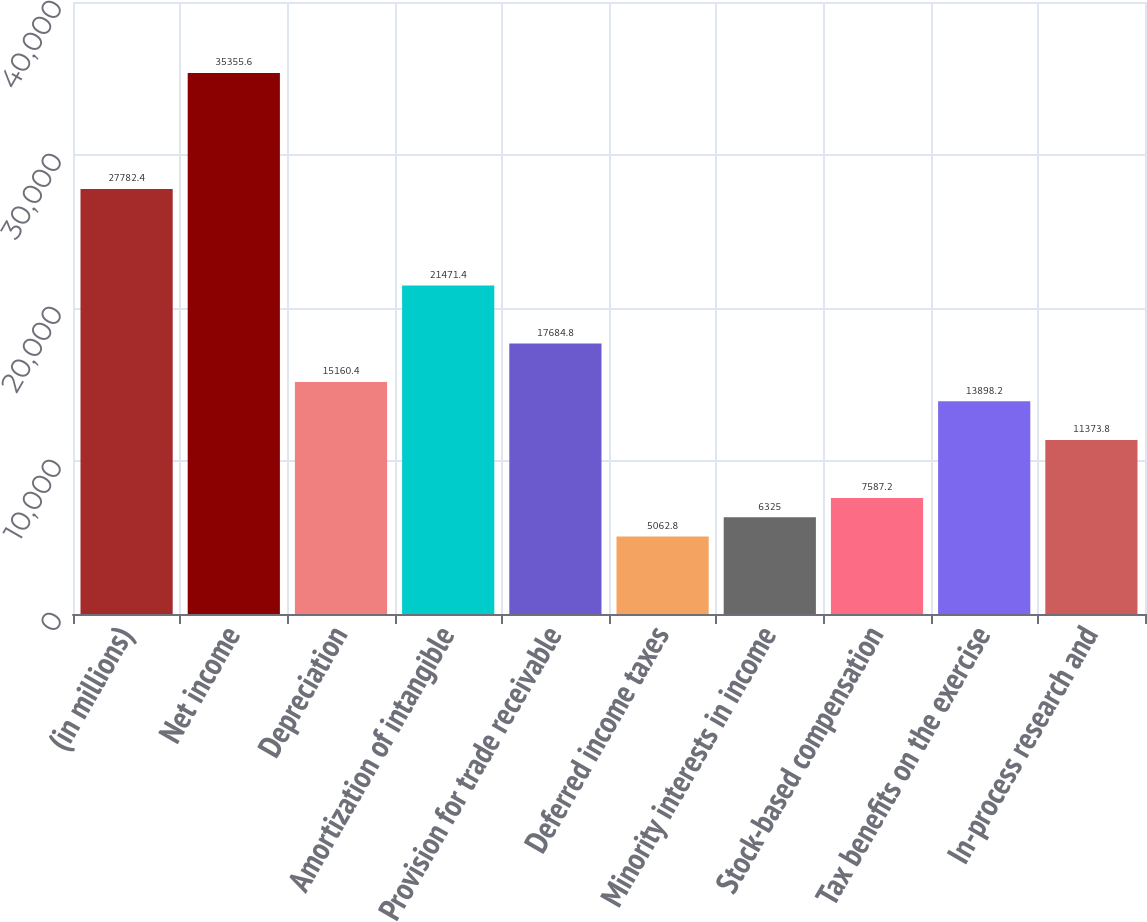<chart> <loc_0><loc_0><loc_500><loc_500><bar_chart><fcel>(in millions)<fcel>Net income<fcel>Depreciation<fcel>Amortization of intangible<fcel>Provision for trade receivable<fcel>Deferred income taxes<fcel>Minority interests in income<fcel>Stock-based compensation<fcel>Tax benefits on the exercise<fcel>In-process research and<nl><fcel>27782.4<fcel>35355.6<fcel>15160.4<fcel>21471.4<fcel>17684.8<fcel>5062.8<fcel>6325<fcel>7587.2<fcel>13898.2<fcel>11373.8<nl></chart> 